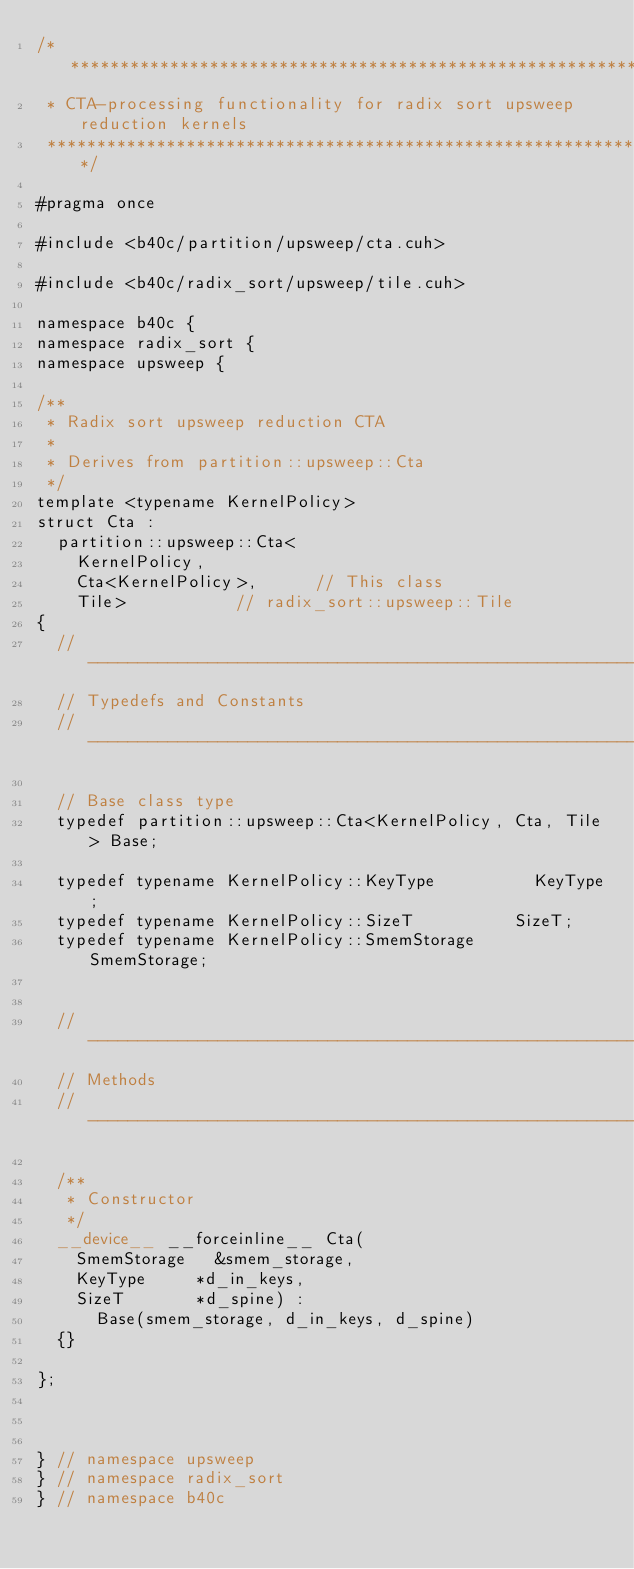Convert code to text. <code><loc_0><loc_0><loc_500><loc_500><_Cuda_>/******************************************************************************
 * CTA-processing functionality for radix sort upsweep reduction kernels
 ******************************************************************************/

#pragma once

#include <b40c/partition/upsweep/cta.cuh>

#include <b40c/radix_sort/upsweep/tile.cuh>

namespace b40c {
namespace radix_sort {
namespace upsweep {

/**
 * Radix sort upsweep reduction CTA
 *
 * Derives from partition::upsweep::Cta
 */
template <typename KernelPolicy>
struct Cta :
	partition::upsweep::Cta<
		KernelPolicy,
		Cta<KernelPolicy>,			// This class
		Tile>						// radix_sort::upsweep::Tile
{
	//---------------------------------------------------------------------
	// Typedefs and Constants
	//---------------------------------------------------------------------

	// Base class type
	typedef partition::upsweep::Cta<KernelPolicy, Cta, Tile> Base;

	typedef typename KernelPolicy::KeyType 					KeyType;
	typedef typename KernelPolicy::SizeT 					SizeT;
	typedef typename KernelPolicy::SmemStorage				SmemStorage;


	//---------------------------------------------------------------------
	// Methods
	//---------------------------------------------------------------------

	/**
	 * Constructor
	 */
	__device__ __forceinline__ Cta(
		SmemStorage 	&smem_storage,
		KeyType 		*d_in_keys,
		SizeT 			*d_spine) :
			Base(smem_storage, d_in_keys, d_spine)
	{}

};



} // namespace upsweep
} // namespace radix_sort
} // namespace b40c

</code> 